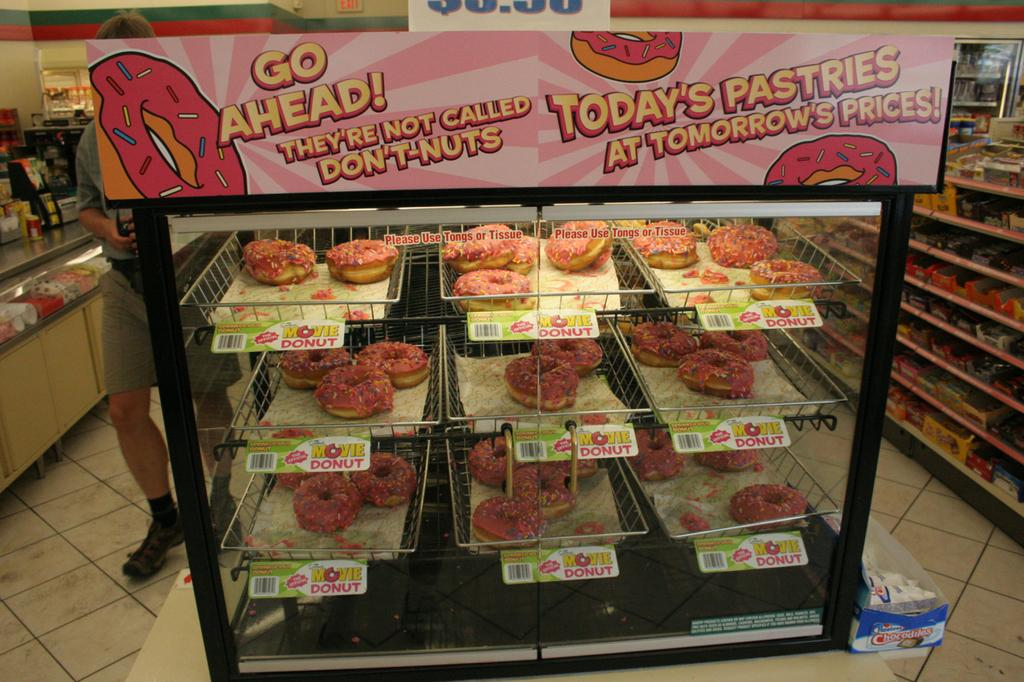<image>
Render a clear and concise summary of the photo. Pink donuts sold as part of The Simpsons Movies advertising. 